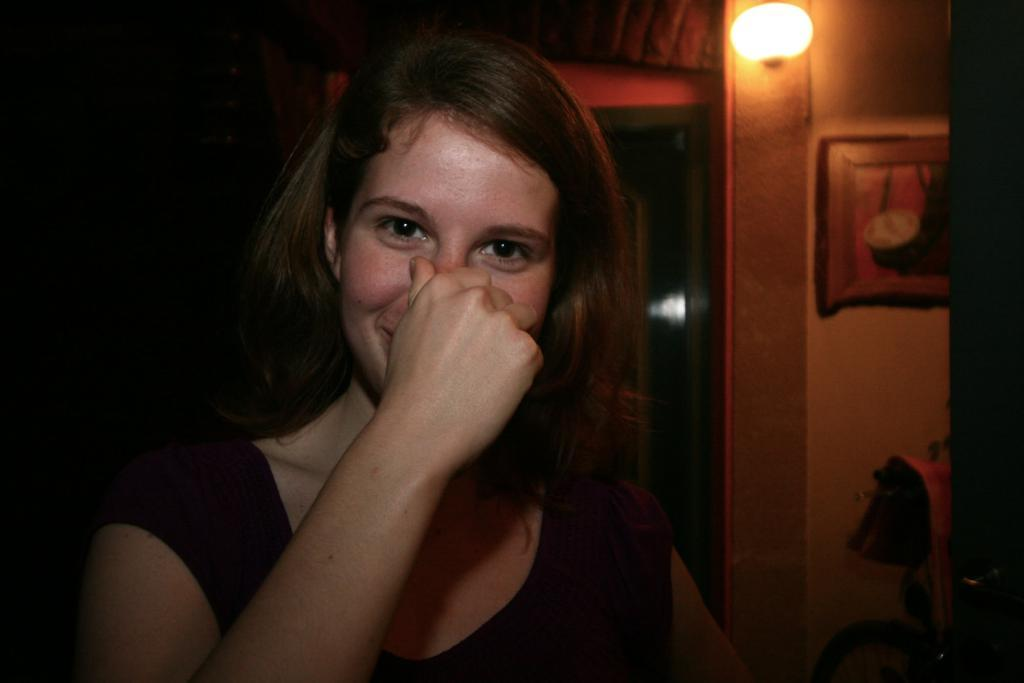Who is the main subject in the image? There is a woman in the image. What is the woman doing with her hand? The woman is touching her nose with her hand. Can you describe the background of the image? There is a dark view, a wall, a light, a photo frame, and other objects visible in the background of the image. How does the woman escape from the quicksand in the image? There is no quicksand present in the image; it only features a woman touching her nose and a background with various objects. 